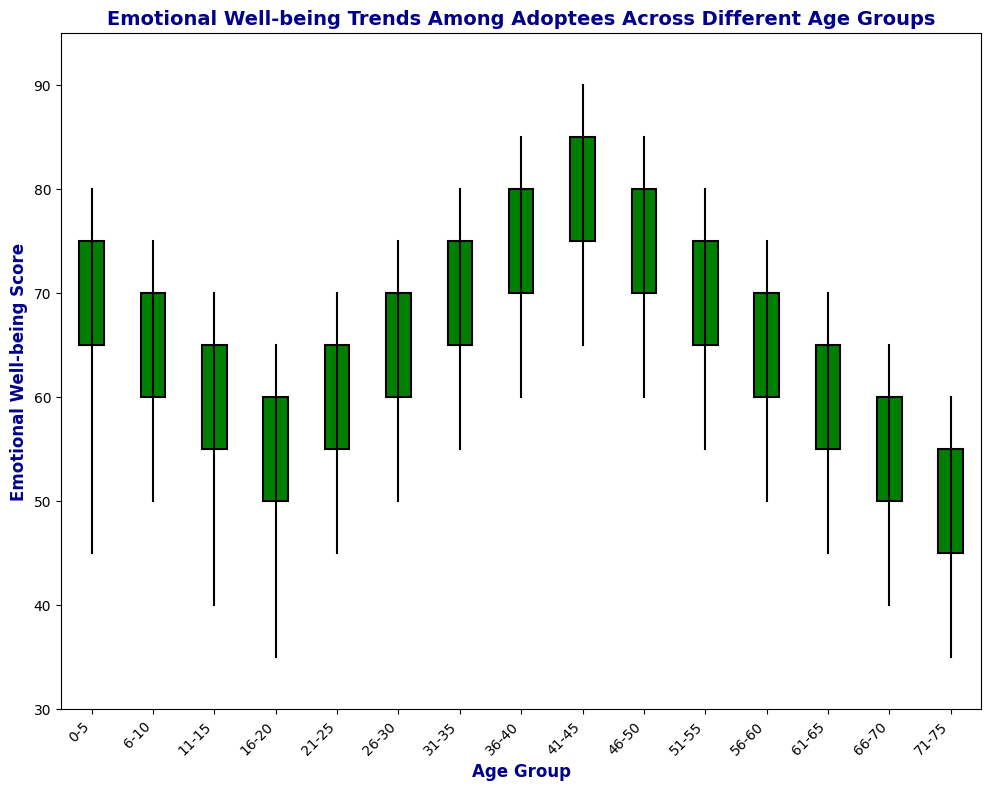What is the trend in emotional well-being scores for adoptees as they age? The trend shows a decline in emotional well-being scores as the age group increases from 0-5 to 71-75. The scores slightly rise for age groups 26-30 to 41-45 before declining again.
Answer: Declining trend Between which age groups do we see an increase in the emotional well-being score from one period to the next? The emotional well-being score increases between the age groups 21-25 to 26-30, 26-30 to 31-35, 31-35 to 36-40, and 36-40 to 41-45.
Answer: 21-25 to 26-30, 26-30 to 31-35, 31-35 to 36-40, and 36-40 to 41-45 Which age group experienced the highest emotional well-being? The age group 41-45 experienced the highest emotional well-being score, with a high of 90.
Answer: 41-45 What is the difference in the highest emotional well-being score between age groups 0-5 and 71-75? The high for the age group 0-5 is 80, and for 71-75 it is 60. The difference is 80 - 60 = 20.
Answer: 20 Which age groups have a 'green' color representing their emotional well-being trend? The age groups 0-5, 21-25, 26-30, 31-35, 36-40, 41-45, and 46-50 have a 'green' color representing their emotional well-being trend.
Answer: 0-5, 21-25, 26-30, 31-35, 36-40, 41-45, 46-50 What age group has the largest range in the emotional well-being score, and what is that range? The age group 41-45 has the largest range. The range is 90 (high) - 65 (low) = 25.
Answer: 41-45, 25 Compare the emotional well-being closing values for the age groups 21-25 and 66-70. Which is higher? The closing value for the age group 21-25 is 65, and for 66-70 it is 60. Thus, 21-25 is higher.
Answer: 21-25 What is the average high value across all the age groups? Sum the high values (80 + 75 + 70 + 65 + 70 + 75 + 80 + 85 + 90 + 85 + 80 + 75 + 70 + 65 + 60) = 1125, and divide by the number of groups (15). The average is 1125 / 15 = 75.
Answer: 75 